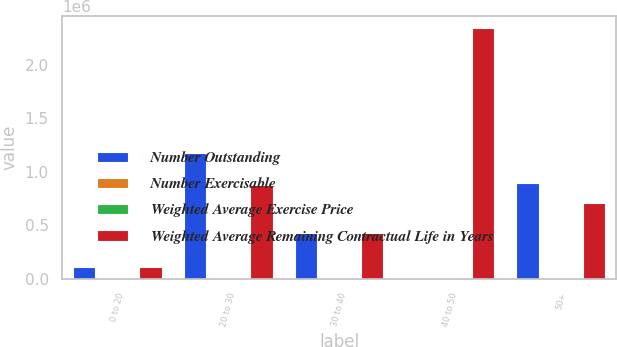Convert chart. <chart><loc_0><loc_0><loc_500><loc_500><stacked_bar_chart><ecel><fcel>0 to 20<fcel>20 to 30<fcel>30 to 40<fcel>40 to 50<fcel>50+<nl><fcel>Number Outstanding<fcel>110762<fcel>1.17711e+06<fcel>426666<fcel>57.71<fcel>899000<nl><fcel>Number Exercisable<fcel>0.8<fcel>5<fcel>6.3<fcel>7.3<fcel>7.3<nl><fcel>Weighted Average Exercise Price<fcel>18.37<fcel>26.15<fcel>38.05<fcel>44.59<fcel>57.71<nl><fcel>Weighted Average Remaining Contractual Life in Years<fcel>110762<fcel>877114<fcel>429962<fcel>2.34063e+06<fcel>706007<nl></chart> 